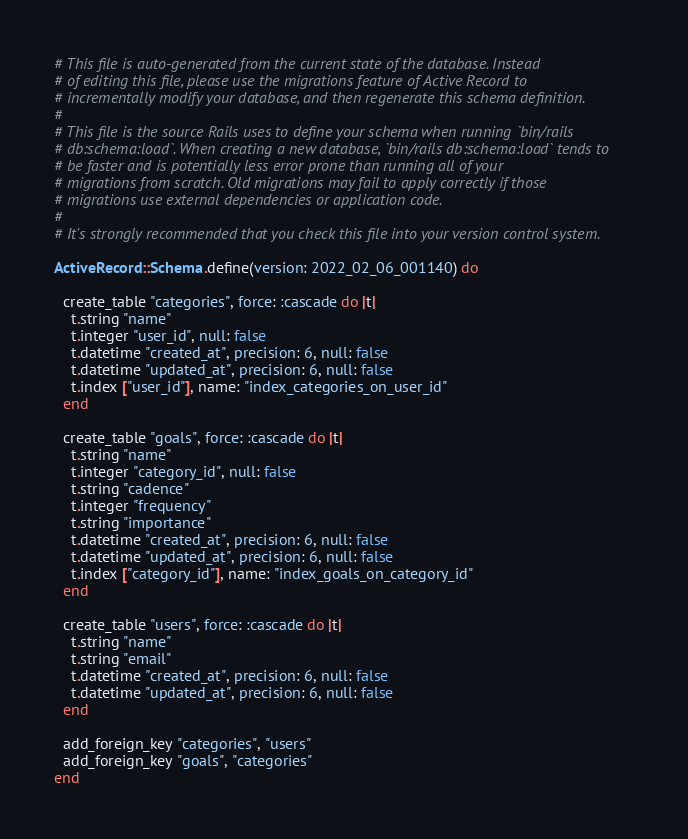<code> <loc_0><loc_0><loc_500><loc_500><_Ruby_># This file is auto-generated from the current state of the database. Instead
# of editing this file, please use the migrations feature of Active Record to
# incrementally modify your database, and then regenerate this schema definition.
#
# This file is the source Rails uses to define your schema when running `bin/rails
# db:schema:load`. When creating a new database, `bin/rails db:schema:load` tends to
# be faster and is potentially less error prone than running all of your
# migrations from scratch. Old migrations may fail to apply correctly if those
# migrations use external dependencies or application code.
#
# It's strongly recommended that you check this file into your version control system.

ActiveRecord::Schema.define(version: 2022_02_06_001140) do

  create_table "categories", force: :cascade do |t|
    t.string "name"
    t.integer "user_id", null: false
    t.datetime "created_at", precision: 6, null: false
    t.datetime "updated_at", precision: 6, null: false
    t.index ["user_id"], name: "index_categories_on_user_id"
  end

  create_table "goals", force: :cascade do |t|
    t.string "name"
    t.integer "category_id", null: false
    t.string "cadence"
    t.integer "frequency"
    t.string "importance"
    t.datetime "created_at", precision: 6, null: false
    t.datetime "updated_at", precision: 6, null: false
    t.index ["category_id"], name: "index_goals_on_category_id"
  end

  create_table "users", force: :cascade do |t|
    t.string "name"
    t.string "email"
    t.datetime "created_at", precision: 6, null: false
    t.datetime "updated_at", precision: 6, null: false
  end

  add_foreign_key "categories", "users"
  add_foreign_key "goals", "categories"
end
</code> 